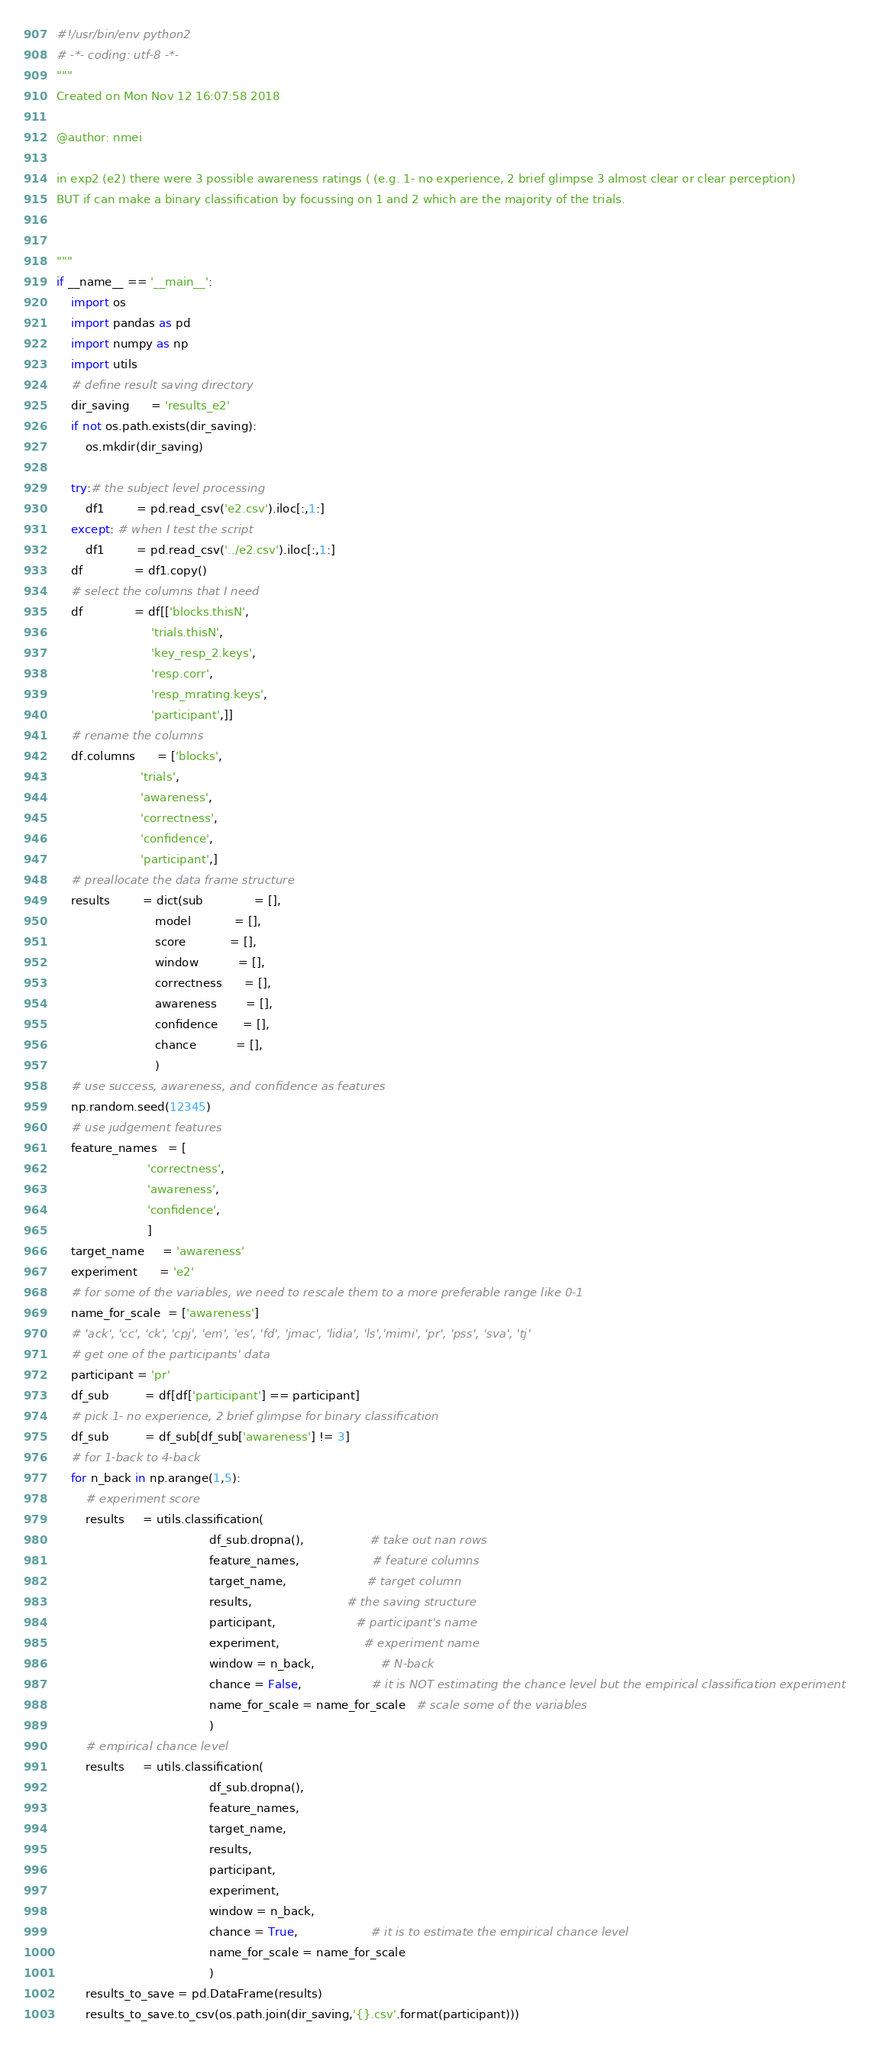<code> <loc_0><loc_0><loc_500><loc_500><_Python_>#!/usr/bin/env python2
# -*- coding: utf-8 -*-
"""
Created on Mon Nov 12 16:07:58 2018

@author: nmei

in exp2 (e2) there were 3 possible awareness ratings ( (e.g. 1- no experience, 2 brief glimpse 3 almost clear or clear perception)
BUT if can make a binary classification by focussing on 1 and 2 which are the majority of the trials.


"""
if __name__ == '__main__':
    import os
    import pandas as pd
    import numpy as np
    import utils
    # define result saving directory
    dir_saving      = 'results_e2'
    if not os.path.exists(dir_saving):
        os.mkdir(dir_saving)
    
    try:# the subject level processing
        df1         = pd.read_csv('e2.csv').iloc[:,1:]
    except: # when I test the script
        df1         = pd.read_csv('../e2.csv').iloc[:,1:]
    df              = df1.copy()
    # select the columns that I need
    df              = df[['blocks.thisN',
                          'trials.thisN',
                          'key_resp_2.keys',
                          'resp.corr',
                          'resp_mrating.keys',
                          'participant',]]
    # rename the columns
    df.columns      = ['blocks',
                       'trials',
                       'awareness',
                       'correctness',
                       'confidence',
                       'participant',]
    # preallocate the data frame structure
    results         = dict(sub              = [],
                           model            = [],
                           score            = [],
                           window           = [],
                           correctness      = [],
                           awareness        = [],
                           confidence       = [],
                           chance           = [],
                           )
    # use success, awareness, and confidence as features
    np.random.seed(12345)
    # use judgement features
    feature_names   = [
                         'correctness',
                         'awareness',
                         'confidence',
                         ]
    target_name     = 'awareness'
    experiment      = 'e2'
    # for some of the variables, we need to rescale them to a more preferable range like 0-1
    name_for_scale  = ['awareness']
    # 'ack', 'cc', 'ck', 'cpj', 'em', 'es', 'fd', 'jmac', 'lidia', 'ls','mimi', 'pr', 'pss', 'sva', 'tj'
    # get one of the participants' data
    participant = 'pr'
    df_sub          = df[df['participant'] == participant]
    # pick 1- no experience, 2 brief glimpse for binary classification
    df_sub          = df_sub[df_sub['awareness'] != 3]
    # for 1-back to 4-back
    for n_back in np.arange(1,5):
        # experiment score
        results     = utils.classification(
                                          df_sub.dropna(),                  # take out nan rows
                                          feature_names,                    # feature columns
                                          target_name,                      # target column
                                          results,                          # the saving structure
                                          participant,                      # participant's name
                                          experiment,                       # experiment name
                                          window = n_back,                  # N-back
                                          chance = False,                   # it is NOT estimating the chance level but the empirical classification experiment
                                          name_for_scale = name_for_scale   # scale some of the variables
                                          )
        # empirical chance level
        results     = utils.classification(
                                          df_sub.dropna(),
                                          feature_names,
                                          target_name,
                                          results,
                                          participant,
                                          experiment,
                                          window = n_back,
                                          chance = True,                    # it is to estimate the empirical chance level
                                          name_for_scale = name_for_scale
                                          )
        results_to_save = pd.DataFrame(results)
        results_to_save.to_csv(os.path.join(dir_saving,'{}.csv'.format(participant)))















































</code> 